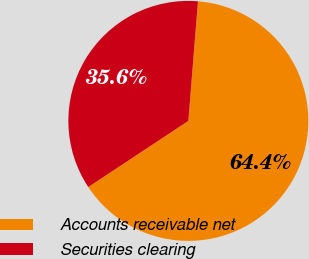Convert chart. <chart><loc_0><loc_0><loc_500><loc_500><pie_chart><fcel>Accounts receivable net<fcel>Securities clearing<nl><fcel>64.43%<fcel>35.57%<nl></chart> 